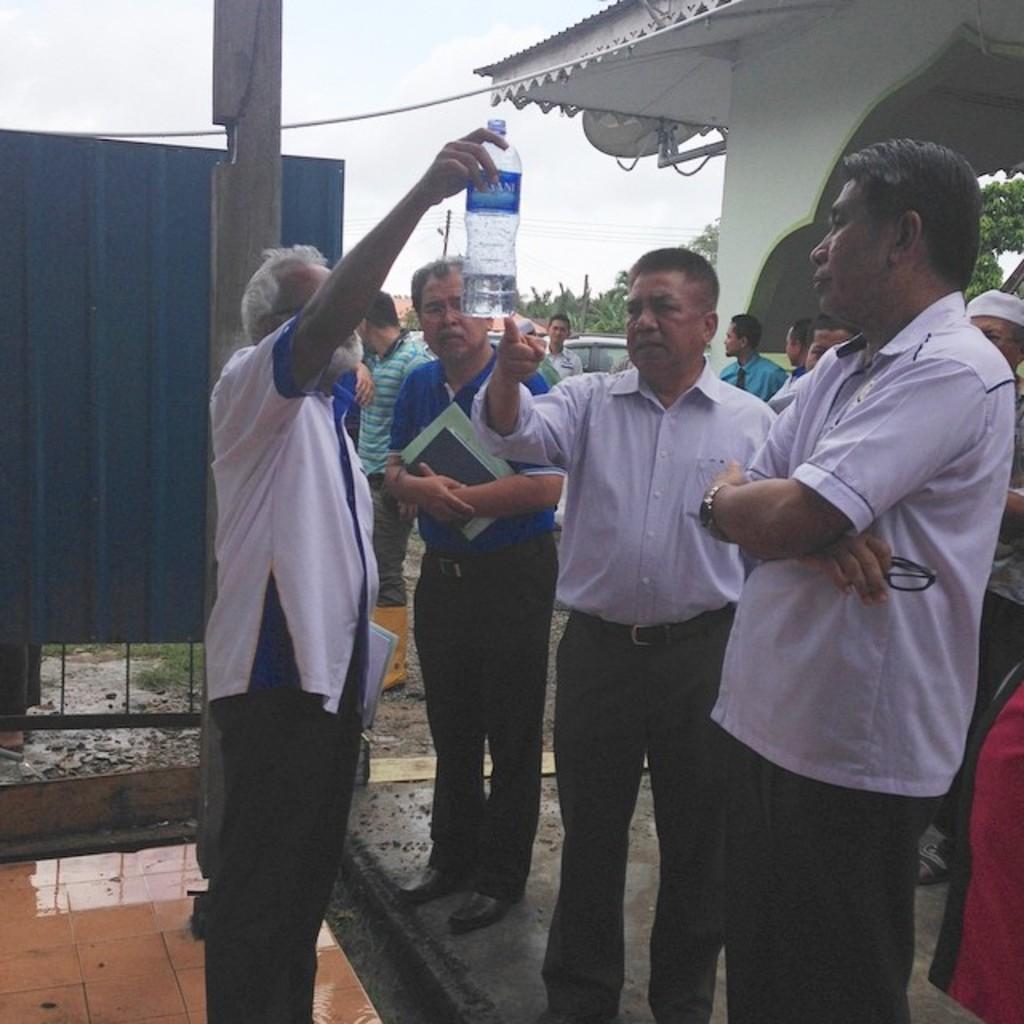Describe this image in one or two sentences. There are few men are standing and looking at the bottle. Behind them there are trees,dish TV hanging on the wall,pole and sky and vehicles. 